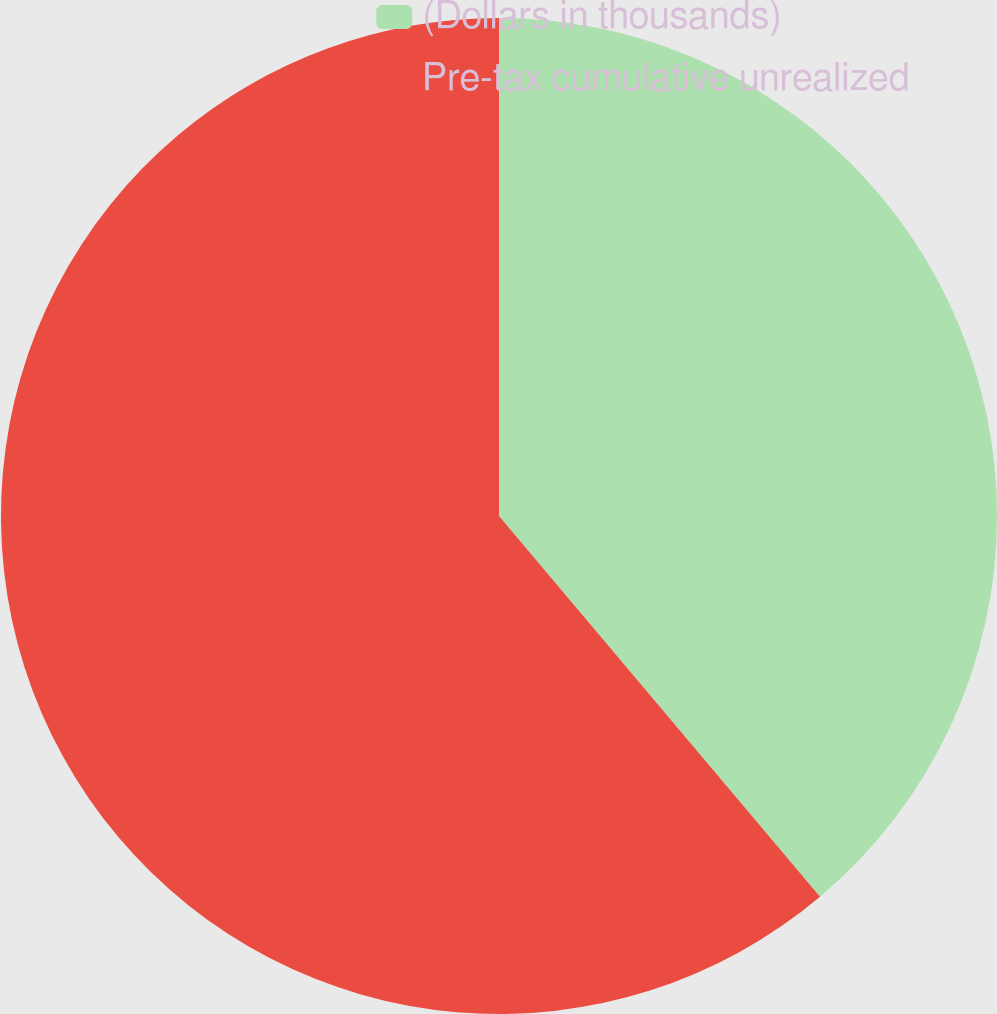Convert chart to OTSL. <chart><loc_0><loc_0><loc_500><loc_500><pie_chart><fcel>(Dollars in thousands)<fcel>Pre-tax cumulative unrealized<nl><fcel>38.85%<fcel>61.15%<nl></chart> 